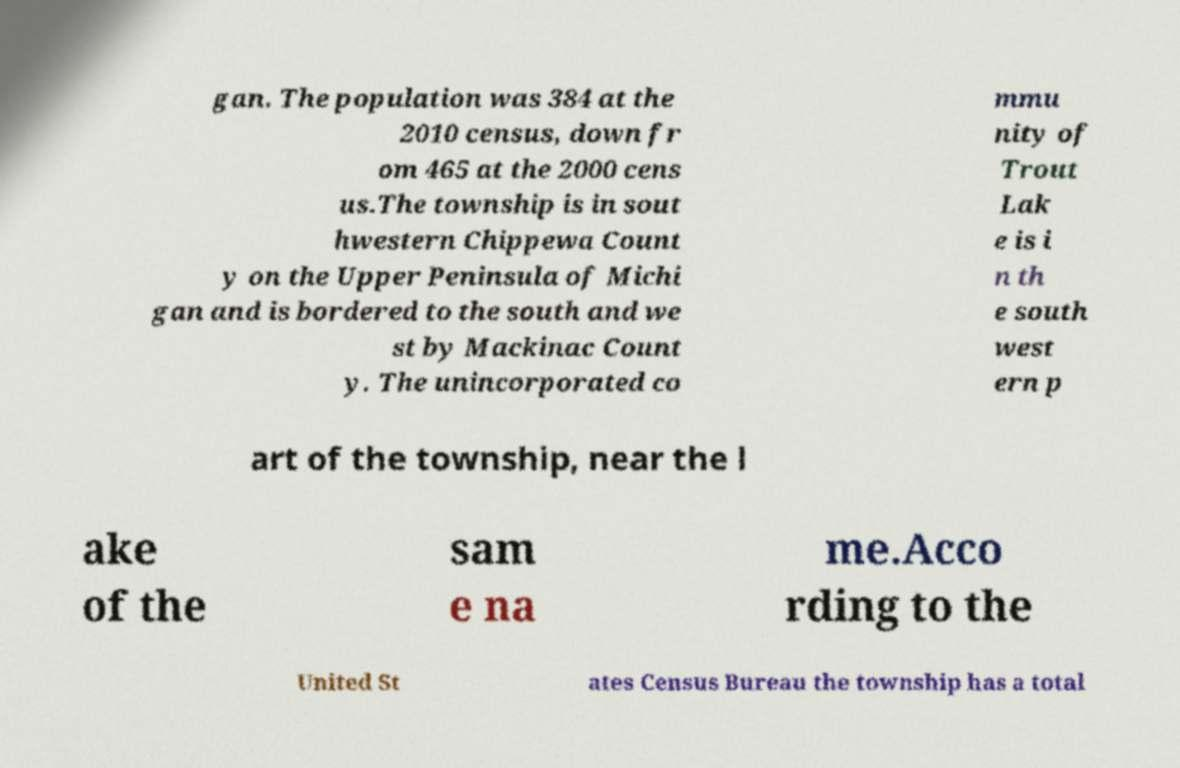For documentation purposes, I need the text within this image transcribed. Could you provide that? gan. The population was 384 at the 2010 census, down fr om 465 at the 2000 cens us.The township is in sout hwestern Chippewa Count y on the Upper Peninsula of Michi gan and is bordered to the south and we st by Mackinac Count y. The unincorporated co mmu nity of Trout Lak e is i n th e south west ern p art of the township, near the l ake of the sam e na me.Acco rding to the United St ates Census Bureau the township has a total 